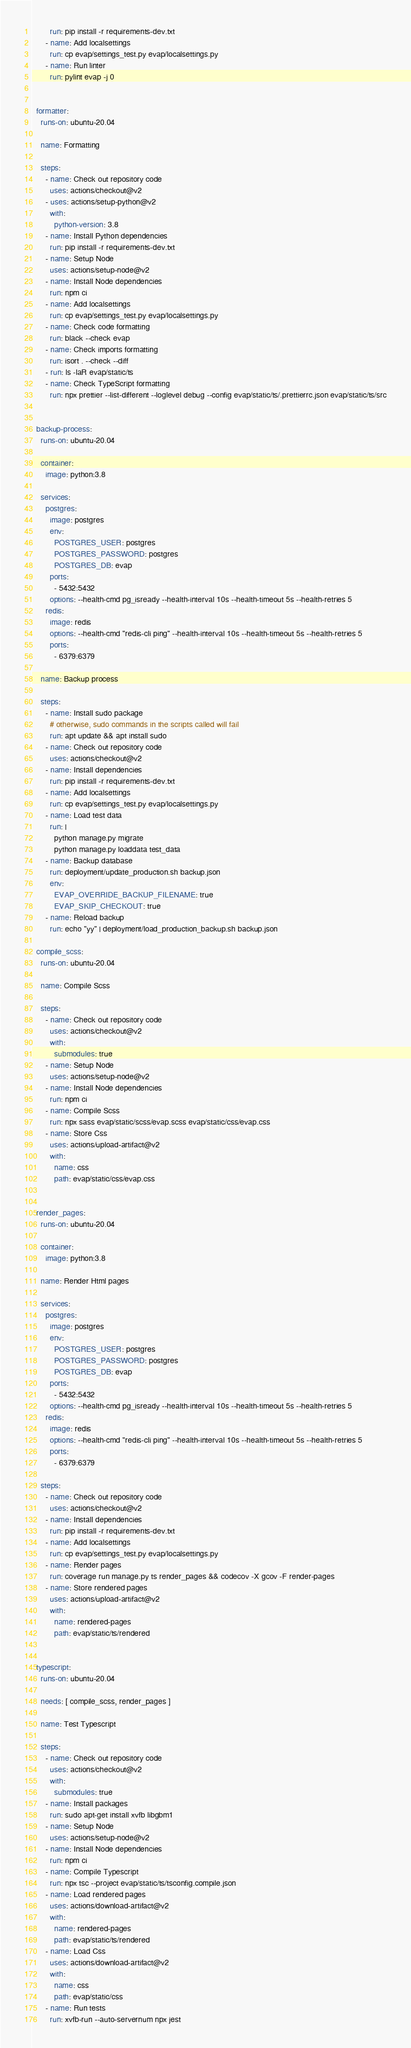Convert code to text. <code><loc_0><loc_0><loc_500><loc_500><_YAML_>        run: pip install -r requirements-dev.txt
      - name: Add localsettings
        run: cp evap/settings_test.py evap/localsettings.py
      - name: Run linter
        run: pylint evap -j 0


  formatter:
    runs-on: ubuntu-20.04

    name: Formatting

    steps:
      - name: Check out repository code
        uses: actions/checkout@v2
      - uses: actions/setup-python@v2
        with:
          python-version: 3.8
      - name: Install Python dependencies
        run: pip install -r requirements-dev.txt
      - name: Setup Node
        uses: actions/setup-node@v2
      - name: Install Node dependencies
        run: npm ci
      - name: Add localsettings
        run: cp evap/settings_test.py evap/localsettings.py
      - name: Check code formatting
        run: black --check evap
      - name: Check imports formatting
        run: isort . --check --diff
      - run: ls -laR evap/static/ts
      - name: Check TypeScript formatting
        run: npx prettier --list-different --loglevel debug --config evap/static/ts/.prettierrc.json evap/static/ts/src


  backup-process:
    runs-on: ubuntu-20.04

    container:
      image: python:3.8

    services:
      postgres:
        image: postgres
        env:
          POSTGRES_USER: postgres
          POSTGRES_PASSWORD: postgres
          POSTGRES_DB: evap
        ports:
          - 5432:5432
        options: --health-cmd pg_isready --health-interval 10s --health-timeout 5s --health-retries 5
      redis:
        image: redis
        options: --health-cmd "redis-cli ping" --health-interval 10s --health-timeout 5s --health-retries 5
        ports:
          - 6379:6379

    name: Backup process

    steps:
      - name: Install sudo package
        # otherwise, sudo commands in the scripts called will fail
        run: apt update && apt install sudo
      - name: Check out repository code
        uses: actions/checkout@v2
      - name: Install dependencies
        run: pip install -r requirements-dev.txt
      - name: Add localsettings
        run: cp evap/settings_test.py evap/localsettings.py
      - name: Load test data
        run: |
          python manage.py migrate
          python manage.py loaddata test_data
      - name: Backup database
        run: deployment/update_production.sh backup.json
        env:
          EVAP_OVERRIDE_BACKUP_FILENAME: true
          EVAP_SKIP_CHECKOUT: true
      - name: Reload backup
        run: echo "yy" | deployment/load_production_backup.sh backup.json

  compile_scss:
    runs-on: ubuntu-20.04

    name: Compile Scss

    steps:
      - name: Check out repository code
        uses: actions/checkout@v2
        with:
          submodules: true
      - name: Setup Node
        uses: actions/setup-node@v2
      - name: Install Node dependencies
        run: npm ci
      - name: Compile Scss
        run: npx sass evap/static/scss/evap.scss evap/static/css/evap.css
      - name: Store Css
        uses: actions/upload-artifact@v2
        with:
          name: css
          path: evap/static/css/evap.css


  render_pages:
    runs-on: ubuntu-20.04

    container:
      image: python:3.8

    name: Render Html pages

    services:
      postgres:
        image: postgres
        env:
          POSTGRES_USER: postgres
          POSTGRES_PASSWORD: postgres
          POSTGRES_DB: evap
        ports:
          - 5432:5432
        options: --health-cmd pg_isready --health-interval 10s --health-timeout 5s --health-retries 5
      redis:
        image: redis
        options: --health-cmd "redis-cli ping" --health-interval 10s --health-timeout 5s --health-retries 5
        ports:
          - 6379:6379

    steps:
      - name: Check out repository code
        uses: actions/checkout@v2
      - name: Install dependencies
        run: pip install -r requirements-dev.txt
      - name: Add localsettings
        run: cp evap/settings_test.py evap/localsettings.py
      - name: Render pages
        run: coverage run manage.py ts render_pages && codecov -X gcov -F render-pages
      - name: Store rendered pages
        uses: actions/upload-artifact@v2
        with:
          name: rendered-pages
          path: evap/static/ts/rendered


  typescript:
    runs-on: ubuntu-20.04

    needs: [ compile_scss, render_pages ]

    name: Test Typescript

    steps:
      - name: Check out repository code
        uses: actions/checkout@v2
        with:
          submodules: true
      - name: Install packages
        run: sudo apt-get install xvfb libgbm1
      - name: Setup Node
        uses: actions/setup-node@v2
      - name: Install Node dependencies
        run: npm ci
      - name: Compile Typescript
        run: npx tsc --project evap/static/ts/tsconfig.compile.json
      - name: Load rendered pages
        uses: actions/download-artifact@v2
        with:
          name: rendered-pages
          path: evap/static/ts/rendered
      - name: Load Css
        uses: actions/download-artifact@v2
        with:
          name: css
          path: evap/static/css
      - name: Run tests
        run: xvfb-run --auto-servernum npx jest
</code> 